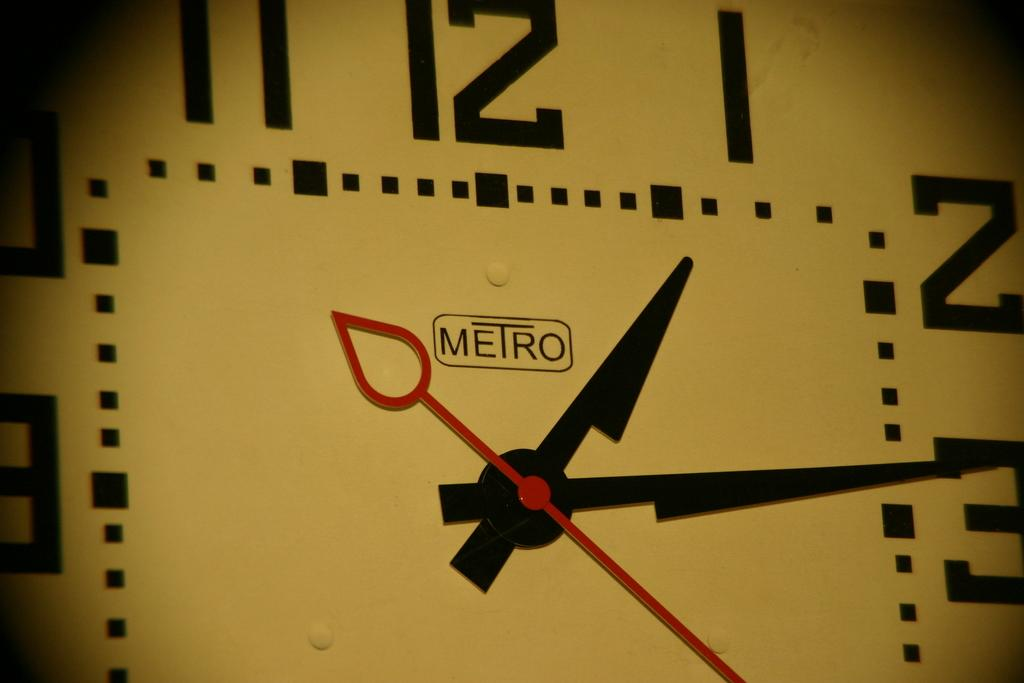<image>
Provide a brief description of the given image. The clock is Metro brand and has a white face, black hands, and a red second hand. 